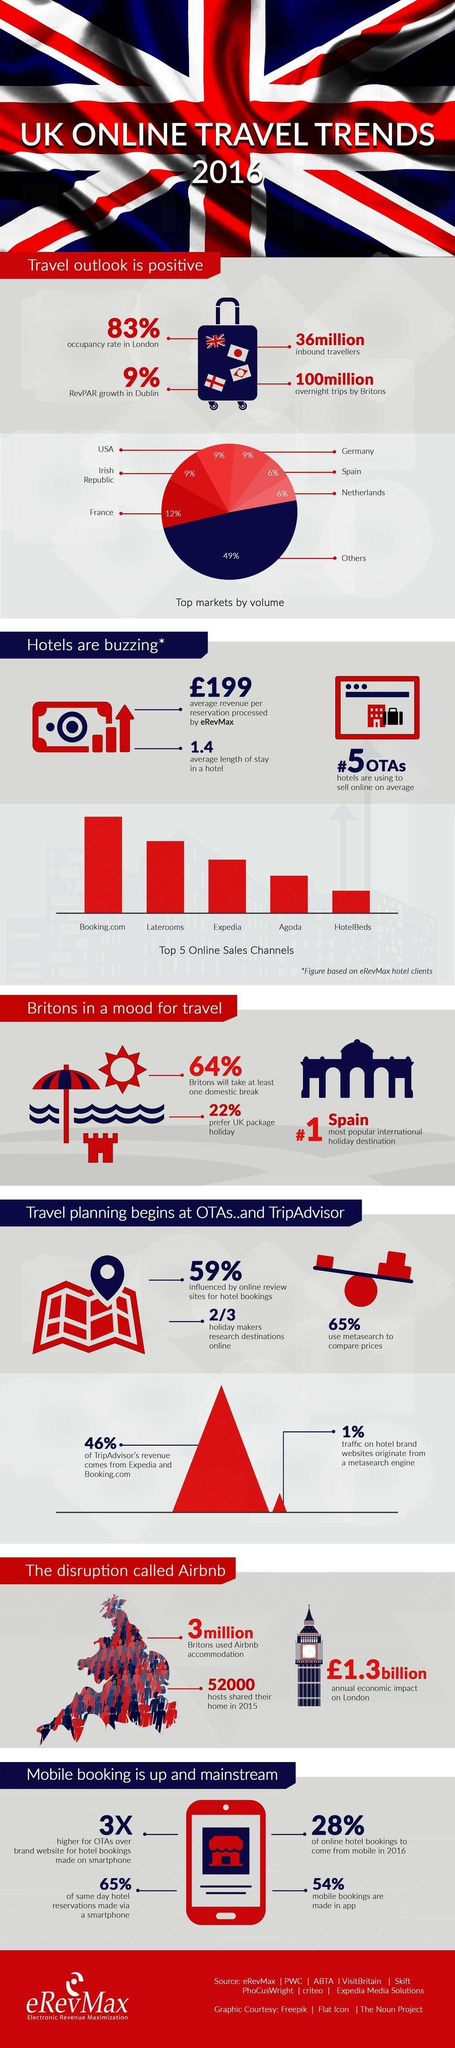How many Britons used Airbnb accommodation in 2016?
Answer the question with a short phrase. 3 million What percentage of mobile bookings were not made in apps in 2016? 46% What percentage of Britons do not prefer UK package holiday? 78% Which is the top online sales channel in UK in 2016? Booking.com Which county is known as the no.1 international holiday destination? Spain What percent of people in UK were not influenced by online review sites for hotel bookings in 2016? 41% 